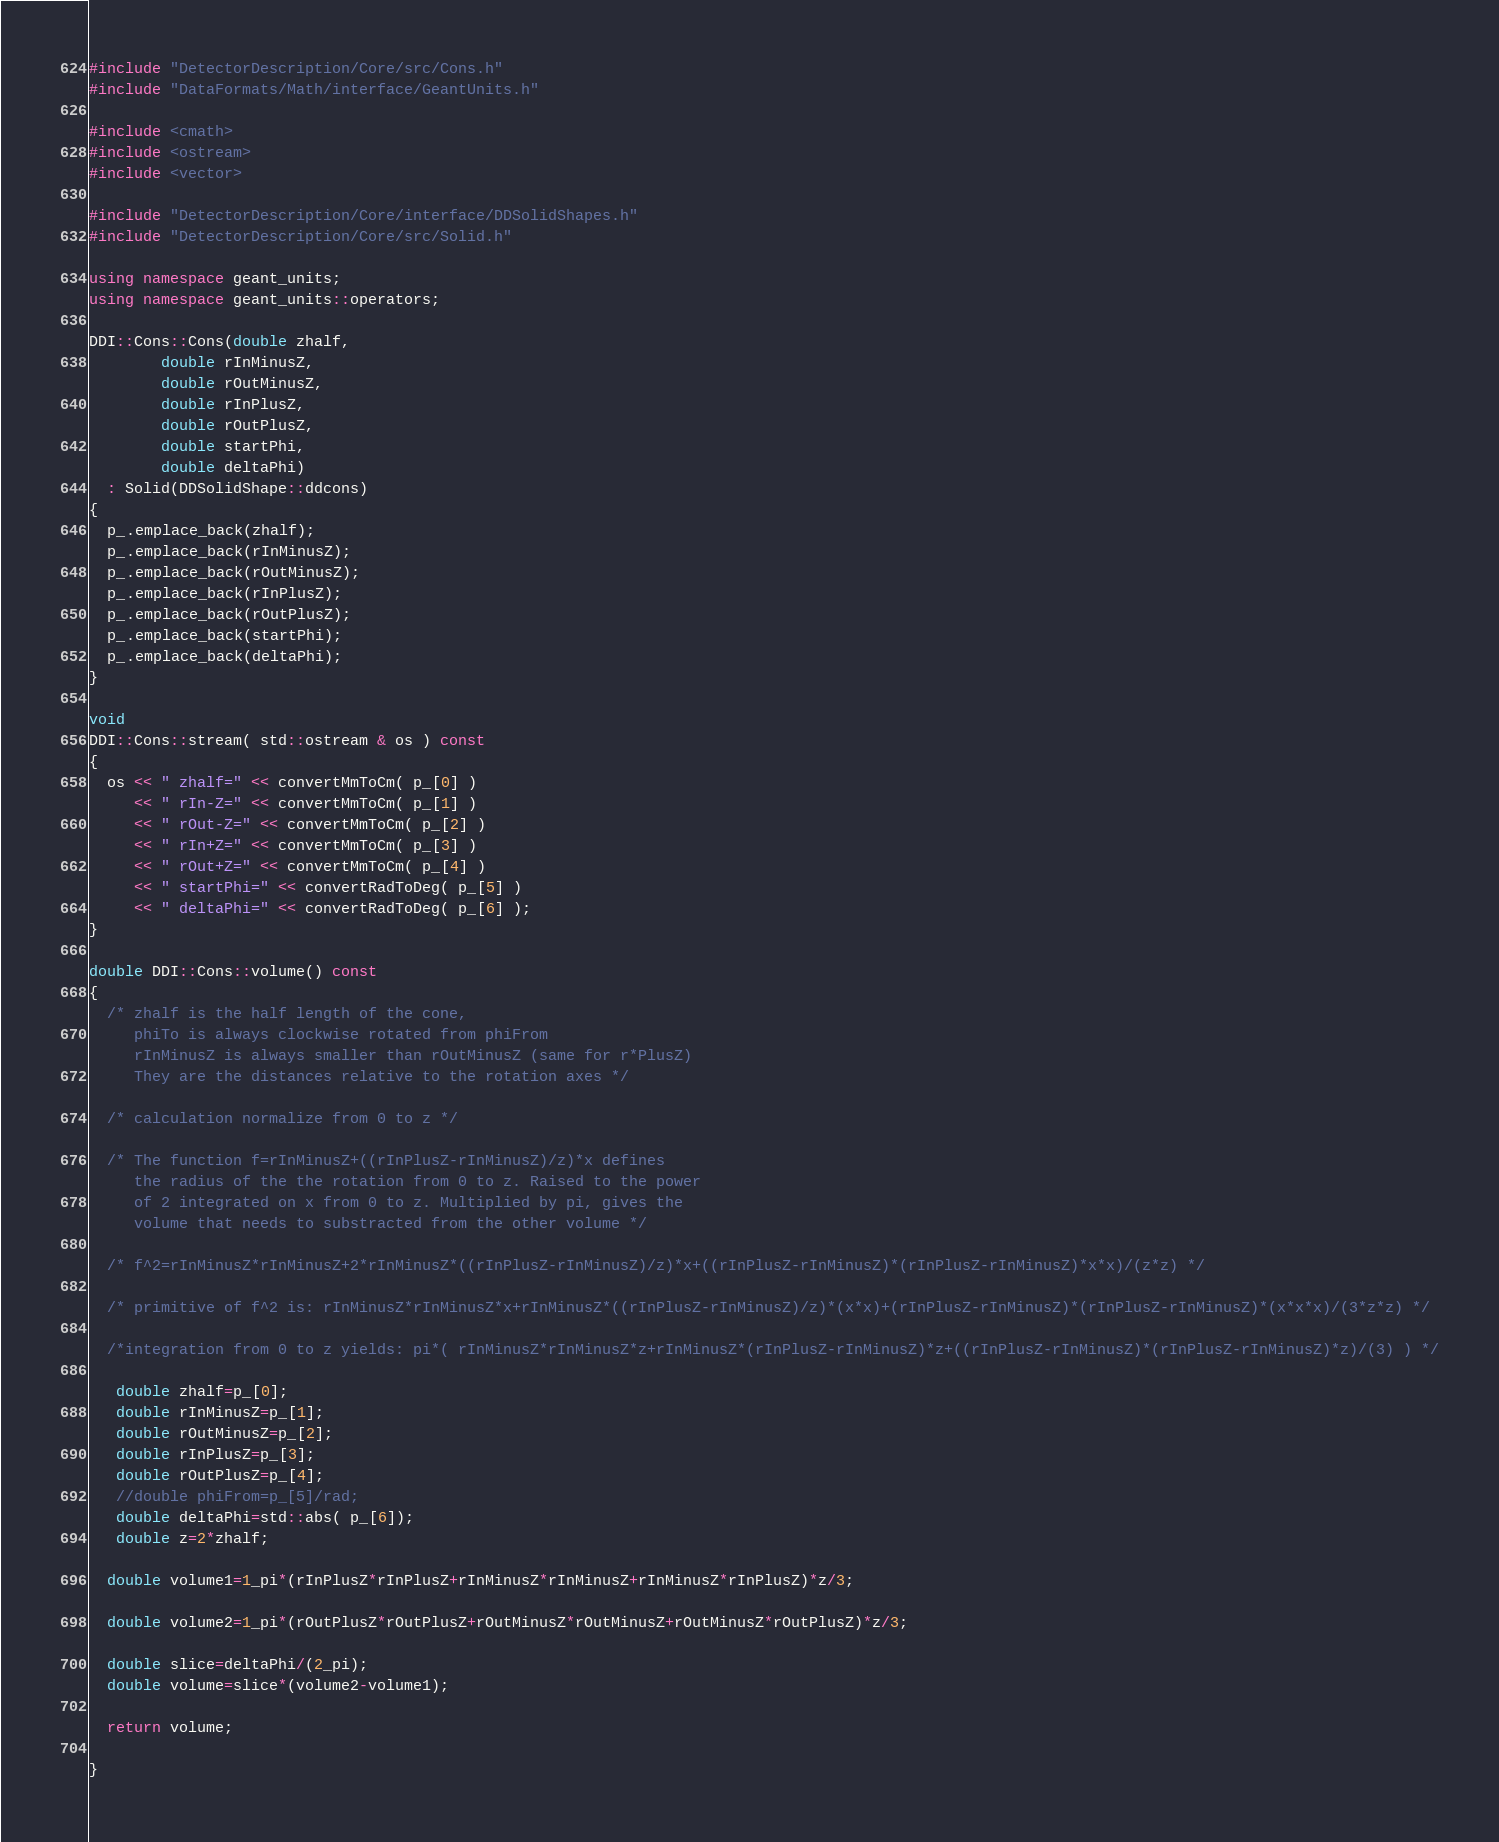<code> <loc_0><loc_0><loc_500><loc_500><_C++_>#include "DetectorDescription/Core/src/Cons.h"
#include "DataFormats/Math/interface/GeantUnits.h"

#include <cmath>
#include <ostream>
#include <vector>

#include "DetectorDescription/Core/interface/DDSolidShapes.h"
#include "DetectorDescription/Core/src/Solid.h"

using namespace geant_units;
using namespace geant_units::operators;

DDI::Cons::Cons(double zhalf,
		double rInMinusZ,
		double rOutMinusZ,
		double rInPlusZ,
		double rOutPlusZ,
		double startPhi,
		double deltaPhi)
  : Solid(DDSolidShape::ddcons)
{
  p_.emplace_back(zhalf);
  p_.emplace_back(rInMinusZ);
  p_.emplace_back(rOutMinusZ);
  p_.emplace_back(rInPlusZ);
  p_.emplace_back(rOutPlusZ);
  p_.emplace_back(startPhi);
  p_.emplace_back(deltaPhi);
}

void
DDI::Cons::stream( std::ostream & os ) const
{
  os << " zhalf=" << convertMmToCm( p_[0] )
     << " rIn-Z=" << convertMmToCm( p_[1] )
     << " rOut-Z=" << convertMmToCm( p_[2] )
     << " rIn+Z=" << convertMmToCm( p_[3] )
     << " rOut+Z=" << convertMmToCm( p_[4] )
     << " startPhi=" << convertRadToDeg( p_[5] )
     << " deltaPhi=" << convertRadToDeg( p_[6] );
}

double DDI::Cons::volume() const
{
  /* zhalf is the half length of the cone,
     phiTo is always clockwise rotated from phiFrom 
     rInMinusZ is always smaller than rOutMinusZ (same for r*PlusZ)
     They are the distances relative to the rotation axes */

  /* calculation normalize from 0 to z */

  /* The function f=rInMinusZ+((rInPlusZ-rInMinusZ)/z)*x defines
     the radius of the the rotation from 0 to z. Raised to the power
     of 2 integrated on x from 0 to z. Multiplied by pi, gives the
     volume that needs to substracted from the other volume */ 
     
  /* f^2=rInMinusZ*rInMinusZ+2*rInMinusZ*((rInPlusZ-rInMinusZ)/z)*x+((rInPlusZ-rInMinusZ)*(rInPlusZ-rInMinusZ)*x*x)/(z*z) */

  /* primitive of f^2 is: rInMinusZ*rInMinusZ*x+rInMinusZ*((rInPlusZ-rInMinusZ)/z)*(x*x)+(rInPlusZ-rInMinusZ)*(rInPlusZ-rInMinusZ)*(x*x*x)/(3*z*z) */

  /*integration from 0 to z yields: pi*( rInMinusZ*rInMinusZ*z+rInMinusZ*(rInPlusZ-rInMinusZ)*z+((rInPlusZ-rInMinusZ)*(rInPlusZ-rInMinusZ)*z)/(3) ) */

   double zhalf=p_[0]; 
   double rInMinusZ=p_[1]; 
   double rOutMinusZ=p_[2]; 
   double rInPlusZ=p_[3]; 
   double rOutPlusZ=p_[4];
   //double phiFrom=p_[5]/rad;
   double deltaPhi=std::abs( p_[6]); 
   double z=2*zhalf;

  double volume1=1_pi*(rInPlusZ*rInPlusZ+rInMinusZ*rInMinusZ+rInMinusZ*rInPlusZ)*z/3;

  double volume2=1_pi*(rOutPlusZ*rOutPlusZ+rOutMinusZ*rOutMinusZ+rOutMinusZ*rOutPlusZ)*z/3;
  
  double slice=deltaPhi/(2_pi);
  double volume=slice*(volume2-volume1);

  return volume;

}


</code> 